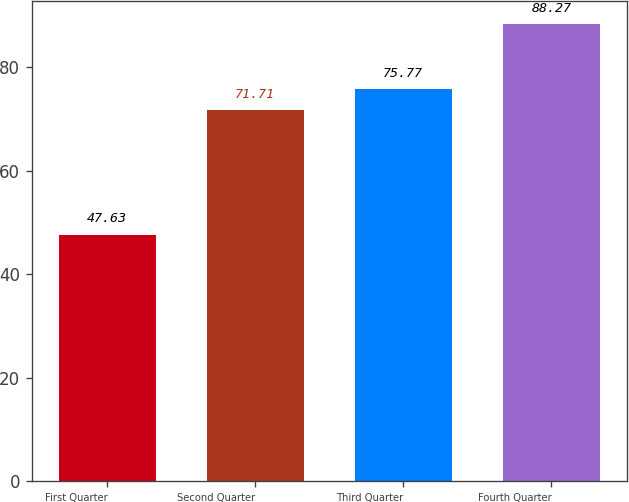Convert chart to OTSL. <chart><loc_0><loc_0><loc_500><loc_500><bar_chart><fcel>First Quarter<fcel>Second Quarter<fcel>Third Quarter<fcel>Fourth Quarter<nl><fcel>47.63<fcel>71.71<fcel>75.77<fcel>88.27<nl></chart> 